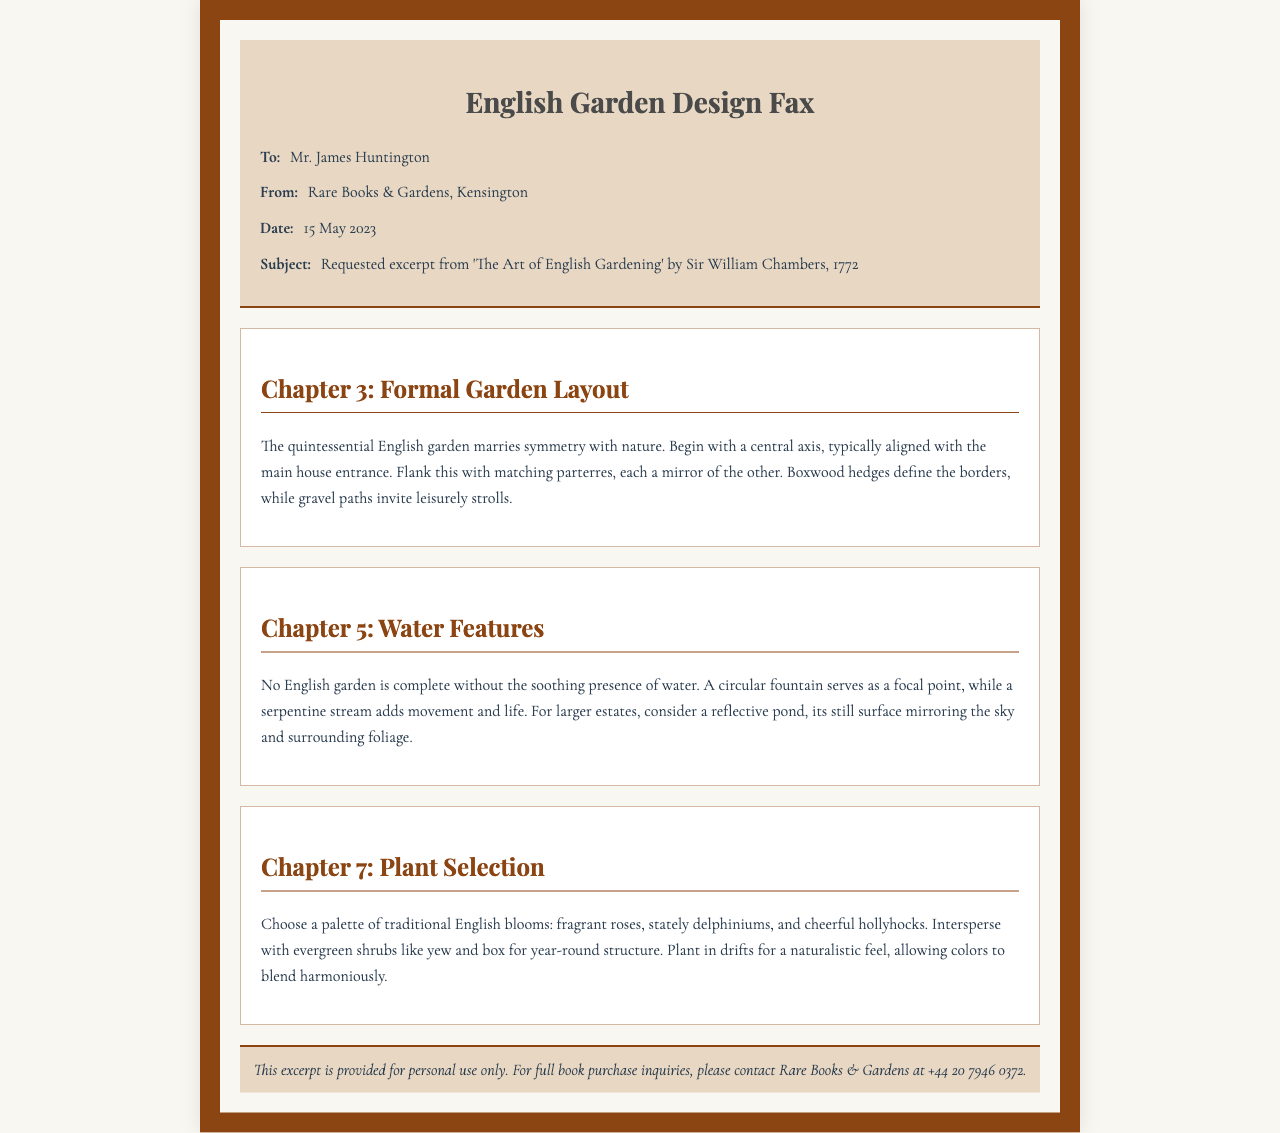What is the name of the book excerpted in the fax? The fax mentions 'The Art of English Gardening' by Sir William Chambers, 1772 as the book being excerpted.
Answer: The Art of English Gardening Who is the fax addressed to? The recipient of the fax is clearly stated at the beginning of the document.
Answer: Mr. James Huntington What is the date of the fax? The date of the fax is provided in the header section.
Answer: 15 May 2023 Which chapter discusses formal garden layout? Chapter 3 is indicated to cover formal garden layout in the document.
Answer: Chapter 3 What type of water feature is suggested as a focal point? The document states a circular fountain is considered as a focal point for the garden's water features.
Answer: Circular fountain Which flowers are mentioned as part of the plant selection? The excerpt mentions fragrant roses, stately delphiniums, and cheerful hollyhocks as part of traditional English blooms.
Answer: Fragrant roses, delphiniums, hollyhocks What contact information is provided for full book purchase inquiries? The footer note includes contact details specifically for inquiring about book purchases.
Answer: +44 20 7946 0372 What design element is highlighted for traditional English gardens? The document emphasizes symmetry as a key design element in traditional English gardens.
Answer: Symmetry 